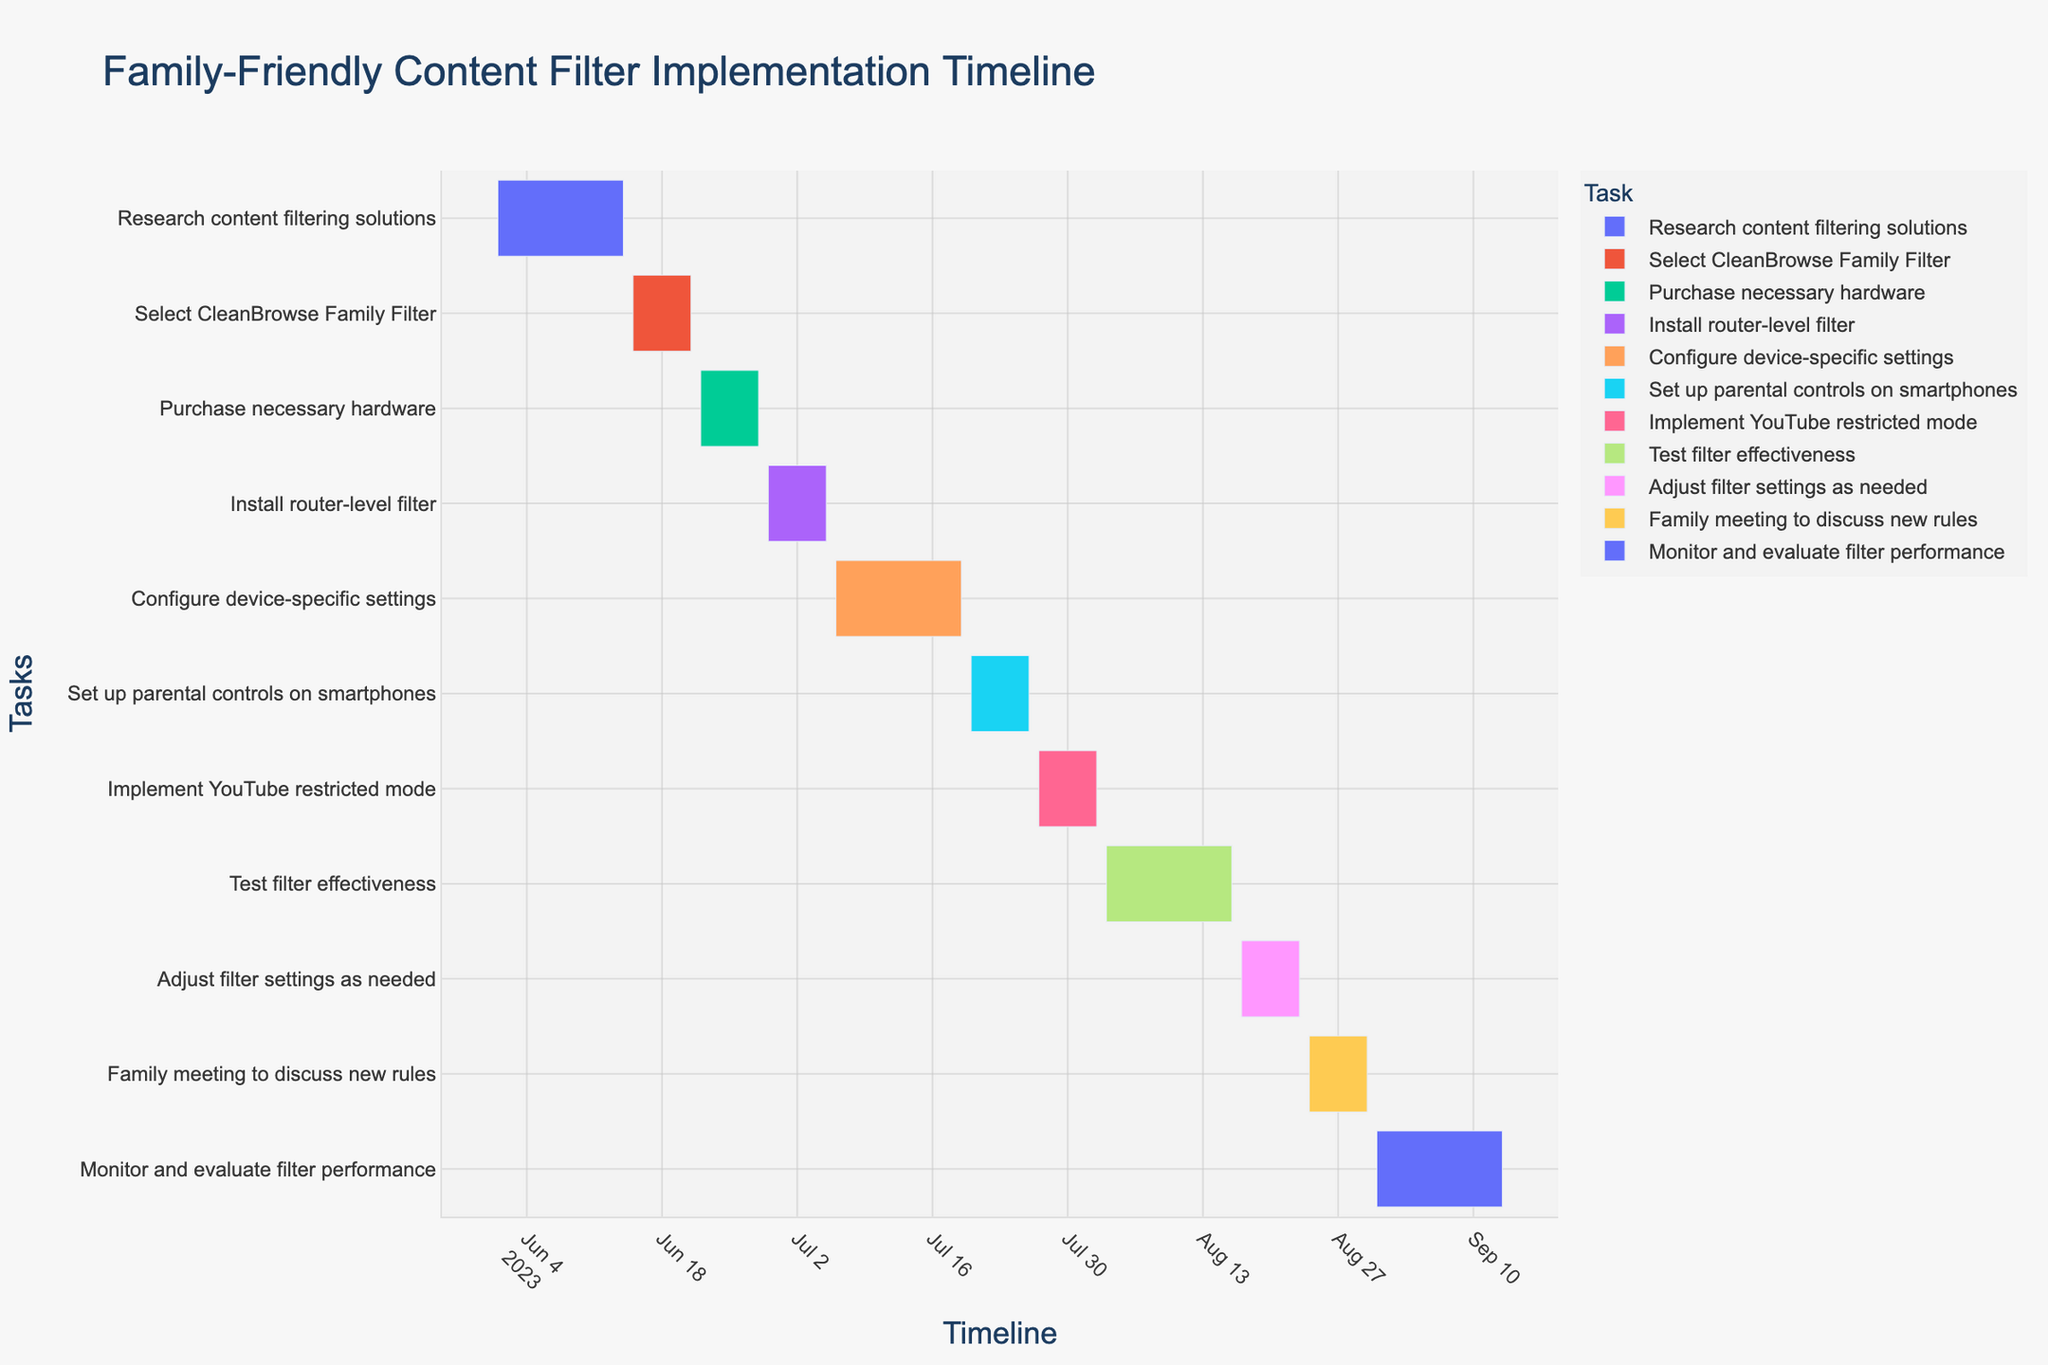What is the title of the chart? The title of the chart is typically located at the top and it summarizes the content of the figure. In this chart, the title is displayed in a larger and distinct font.
Answer: Family-Friendly Content Filter Implementation Timeline Which task has the longest duration? To find the task with the longest duration, look at the lengths of the bars representing each task. The task with the longest bar indicates the longest duration.
Answer: Monitor and evaluate filter performance How many tasks are scheduled to last exactly 7 days? Scan the chart for bars representing tasks and count the bars that span exactly 7 days on the timeline.
Answer: 6 What is the total duration from the start of the first task to the end of the last task? Identify the start date of the first task and the end date of the last task, then calculate the duration between these two dates.
Answer: 106 days Which task follows 'Install router-level filter'? Locate the 'Install router-level filter' task on the timeline. The task that starts immediately after this one is the next task.
Answer: Configure device-specific settings What is the combined duration of the tasks 'Test filter effectiveness' and 'Adjust filter settings as needed'? Identify the duration of each task separately, then add them together to get the total duration.
Answer: 21 days How many tasks are there in total? Count the number of distinct bars on the Gantt chart, as each bar represents a single task.
Answer: 11 Which task has the earliest start date? Locate the earliest date on the timeline and find the task that starts at that point.
Answer: Research content filtering solutions Compare the duration of 'Set up parental controls on smartphones' and 'Implement YouTube restricted mode'. Which one is longer? Identify the duration of both tasks on the timeline and compare their lengths.
Answer: Both are the same By how many days does the 'Family meeting to discuss new rules' task extend beyond the 'Adjust filter settings as needed' task? Determine the end date of the 'Adjust filter settings as needed' task and the end date of the 'Family meeting to discuss new rules', then subtract to find the difference.
Answer: 0 days 